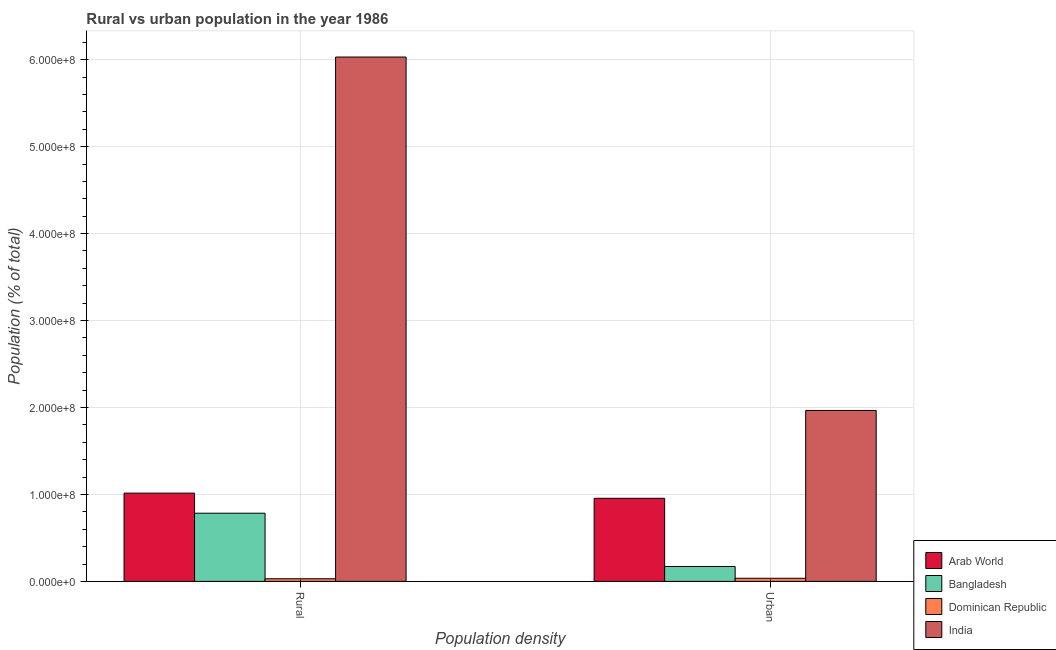Are the number of bars on each tick of the X-axis equal?
Your answer should be very brief. Yes. How many bars are there on the 1st tick from the left?
Your response must be concise. 4. What is the label of the 1st group of bars from the left?
Keep it short and to the point. Rural. What is the rural population density in Dominican Republic?
Your answer should be compact. 3.04e+06. Across all countries, what is the maximum rural population density?
Your answer should be compact. 6.03e+08. Across all countries, what is the minimum urban population density?
Offer a terse response. 3.59e+06. In which country was the rural population density maximum?
Provide a succinct answer. India. In which country was the rural population density minimum?
Your response must be concise. Dominican Republic. What is the total rural population density in the graph?
Offer a terse response. 7.86e+08. What is the difference between the rural population density in India and that in Arab World?
Provide a short and direct response. 5.02e+08. What is the difference between the urban population density in Dominican Republic and the rural population density in India?
Ensure brevity in your answer.  -5.99e+08. What is the average rural population density per country?
Provide a short and direct response. 1.96e+08. What is the difference between the rural population density and urban population density in Bangladesh?
Give a very brief answer. 6.13e+07. What is the ratio of the urban population density in Bangladesh to that in Arab World?
Provide a succinct answer. 0.18. Are the values on the major ticks of Y-axis written in scientific E-notation?
Provide a short and direct response. Yes. Does the graph contain any zero values?
Provide a short and direct response. No. Does the graph contain grids?
Your response must be concise. Yes. How many legend labels are there?
Offer a very short reply. 4. What is the title of the graph?
Give a very brief answer. Rural vs urban population in the year 1986. What is the label or title of the X-axis?
Your answer should be very brief. Population density. What is the label or title of the Y-axis?
Your answer should be compact. Population (% of total). What is the Population (% of total) in Arab World in Rural?
Your answer should be compact. 1.02e+08. What is the Population (% of total) of Bangladesh in Rural?
Your answer should be very brief. 7.84e+07. What is the Population (% of total) in Dominican Republic in Rural?
Provide a succinct answer. 3.04e+06. What is the Population (% of total) of India in Rural?
Ensure brevity in your answer.  6.03e+08. What is the Population (% of total) in Arab World in Urban?
Offer a terse response. 9.55e+07. What is the Population (% of total) in Bangladesh in Urban?
Offer a very short reply. 1.71e+07. What is the Population (% of total) in Dominican Republic in Urban?
Give a very brief answer. 3.59e+06. What is the Population (% of total) of India in Urban?
Ensure brevity in your answer.  1.97e+08. Across all Population density, what is the maximum Population (% of total) of Arab World?
Provide a succinct answer. 1.02e+08. Across all Population density, what is the maximum Population (% of total) of Bangladesh?
Offer a very short reply. 7.84e+07. Across all Population density, what is the maximum Population (% of total) of Dominican Republic?
Keep it short and to the point. 3.59e+06. Across all Population density, what is the maximum Population (% of total) of India?
Keep it short and to the point. 6.03e+08. Across all Population density, what is the minimum Population (% of total) of Arab World?
Your answer should be very brief. 9.55e+07. Across all Population density, what is the minimum Population (% of total) in Bangladesh?
Make the answer very short. 1.71e+07. Across all Population density, what is the minimum Population (% of total) of Dominican Republic?
Provide a short and direct response. 3.04e+06. Across all Population density, what is the minimum Population (% of total) in India?
Provide a short and direct response. 1.97e+08. What is the total Population (% of total) of Arab World in the graph?
Offer a terse response. 1.97e+08. What is the total Population (% of total) of Bangladesh in the graph?
Give a very brief answer. 9.56e+07. What is the total Population (% of total) of Dominican Republic in the graph?
Offer a very short reply. 6.63e+06. What is the total Population (% of total) of India in the graph?
Offer a terse response. 8.00e+08. What is the difference between the Population (% of total) in Arab World in Rural and that in Urban?
Provide a short and direct response. 5.97e+06. What is the difference between the Population (% of total) of Bangladesh in Rural and that in Urban?
Keep it short and to the point. 6.13e+07. What is the difference between the Population (% of total) in Dominican Republic in Rural and that in Urban?
Make the answer very short. -5.49e+05. What is the difference between the Population (% of total) of India in Rural and that in Urban?
Provide a short and direct response. 4.06e+08. What is the difference between the Population (% of total) in Arab World in Rural and the Population (% of total) in Bangladesh in Urban?
Provide a succinct answer. 8.44e+07. What is the difference between the Population (% of total) in Arab World in Rural and the Population (% of total) in Dominican Republic in Urban?
Provide a succinct answer. 9.79e+07. What is the difference between the Population (% of total) in Arab World in Rural and the Population (% of total) in India in Urban?
Ensure brevity in your answer.  -9.51e+07. What is the difference between the Population (% of total) in Bangladesh in Rural and the Population (% of total) in Dominican Republic in Urban?
Provide a short and direct response. 7.48e+07. What is the difference between the Population (% of total) of Bangladesh in Rural and the Population (% of total) of India in Urban?
Offer a terse response. -1.18e+08. What is the difference between the Population (% of total) in Dominican Republic in Rural and the Population (% of total) in India in Urban?
Offer a terse response. -1.94e+08. What is the average Population (% of total) in Arab World per Population density?
Offer a very short reply. 9.85e+07. What is the average Population (% of total) in Bangladesh per Population density?
Your answer should be very brief. 4.78e+07. What is the average Population (% of total) of Dominican Republic per Population density?
Offer a very short reply. 3.31e+06. What is the average Population (% of total) in India per Population density?
Ensure brevity in your answer.  4.00e+08. What is the difference between the Population (% of total) in Arab World and Population (% of total) in Bangladesh in Rural?
Ensure brevity in your answer.  2.31e+07. What is the difference between the Population (% of total) of Arab World and Population (% of total) of Dominican Republic in Rural?
Your answer should be compact. 9.85e+07. What is the difference between the Population (% of total) of Arab World and Population (% of total) of India in Rural?
Your response must be concise. -5.02e+08. What is the difference between the Population (% of total) in Bangladesh and Population (% of total) in Dominican Republic in Rural?
Provide a succinct answer. 7.54e+07. What is the difference between the Population (% of total) in Bangladesh and Population (% of total) in India in Rural?
Provide a short and direct response. -5.25e+08. What is the difference between the Population (% of total) in Dominican Republic and Population (% of total) in India in Rural?
Provide a short and direct response. -6.00e+08. What is the difference between the Population (% of total) in Arab World and Population (% of total) in Bangladesh in Urban?
Provide a short and direct response. 7.84e+07. What is the difference between the Population (% of total) in Arab World and Population (% of total) in Dominican Republic in Urban?
Provide a short and direct response. 9.20e+07. What is the difference between the Population (% of total) of Arab World and Population (% of total) of India in Urban?
Ensure brevity in your answer.  -1.01e+08. What is the difference between the Population (% of total) in Bangladesh and Population (% of total) in Dominican Republic in Urban?
Offer a terse response. 1.36e+07. What is the difference between the Population (% of total) of Bangladesh and Population (% of total) of India in Urban?
Give a very brief answer. -1.79e+08. What is the difference between the Population (% of total) in Dominican Republic and Population (% of total) in India in Urban?
Give a very brief answer. -1.93e+08. What is the ratio of the Population (% of total) in Bangladesh in Rural to that in Urban?
Provide a succinct answer. 4.57. What is the ratio of the Population (% of total) of Dominican Republic in Rural to that in Urban?
Offer a very short reply. 0.85. What is the ratio of the Population (% of total) in India in Rural to that in Urban?
Ensure brevity in your answer.  3.07. What is the difference between the highest and the second highest Population (% of total) in Arab World?
Keep it short and to the point. 5.97e+06. What is the difference between the highest and the second highest Population (% of total) of Bangladesh?
Make the answer very short. 6.13e+07. What is the difference between the highest and the second highest Population (% of total) of Dominican Republic?
Your response must be concise. 5.49e+05. What is the difference between the highest and the second highest Population (% of total) of India?
Give a very brief answer. 4.06e+08. What is the difference between the highest and the lowest Population (% of total) in Arab World?
Offer a terse response. 5.97e+06. What is the difference between the highest and the lowest Population (% of total) of Bangladesh?
Your answer should be compact. 6.13e+07. What is the difference between the highest and the lowest Population (% of total) of Dominican Republic?
Your answer should be very brief. 5.49e+05. What is the difference between the highest and the lowest Population (% of total) in India?
Provide a short and direct response. 4.06e+08. 